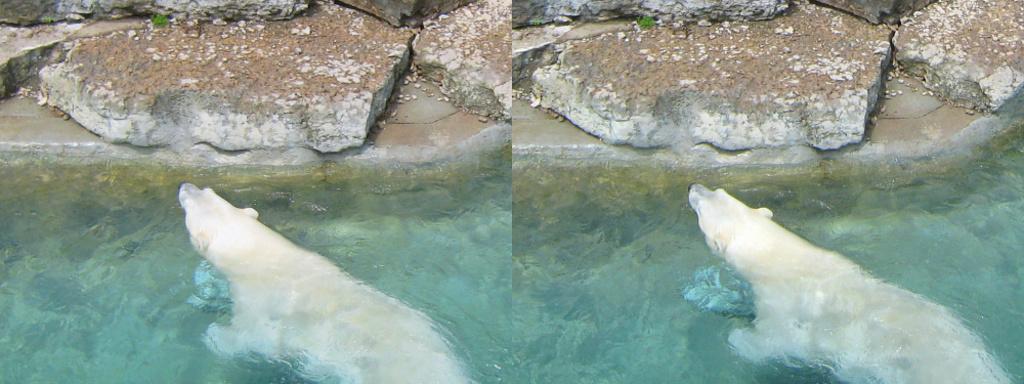Can you describe this image briefly? In this college image there is a bear in the water and stones at the top side. 